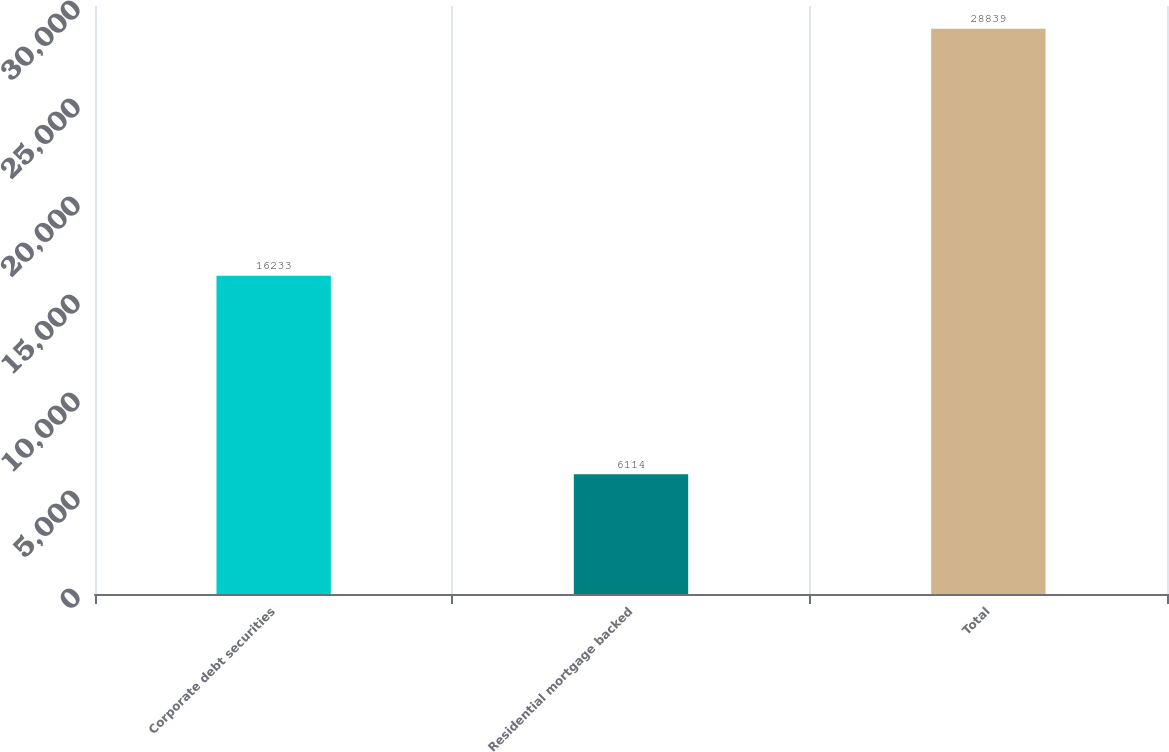Convert chart to OTSL. <chart><loc_0><loc_0><loc_500><loc_500><bar_chart><fcel>Corporate debt securities<fcel>Residential mortgage backed<fcel>Total<nl><fcel>16233<fcel>6114<fcel>28839<nl></chart> 